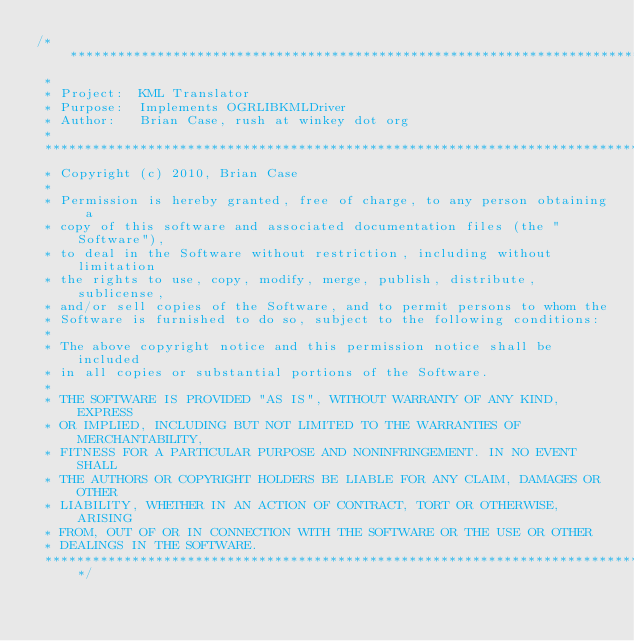Convert code to text. <code><loc_0><loc_0><loc_500><loc_500><_C++_>/******************************************************************************
 *
 * Project:  KML Translator
 * Purpose:  Implements OGRLIBKMLDriver
 * Author:   Brian Case, rush at winkey dot org
 *
 ******************************************************************************
 * Copyright (c) 2010, Brian Case
 *
 * Permission is hereby granted, free of charge, to any person obtaining a
 * copy of this software and associated documentation files (the "Software"),
 * to deal in the Software without restriction, including without limitation
 * the rights to use, copy, modify, merge, publish, distribute, sublicense,
 * and/or sell copies of the Software, and to permit persons to whom the
 * Software is furnished to do so, subject to the following conditions:
 *
 * The above copyright notice and this permission notice shall be included
 * in all copies or substantial portions of the Software.
 *
 * THE SOFTWARE IS PROVIDED "AS IS", WITHOUT WARRANTY OF ANY KIND, EXPRESS
 * OR IMPLIED, INCLUDING BUT NOT LIMITED TO THE WARRANTIES OF MERCHANTABILITY,
 * FITNESS FOR A PARTICULAR PURPOSE AND NONINFRINGEMENT. IN NO EVENT SHALL
 * THE AUTHORS OR COPYRIGHT HOLDERS BE LIABLE FOR ANY CLAIM, DAMAGES OR OTHER
 * LIABILITY, WHETHER IN AN ACTION OF CONTRACT, TORT OR OTHERWISE, ARISING
 * FROM, OUT OF OR IN CONNECTION WITH THE SOFTWARE OR THE USE OR OTHER
 * DEALINGS IN THE SOFTWARE.
 *****************************************************************************/
</code> 